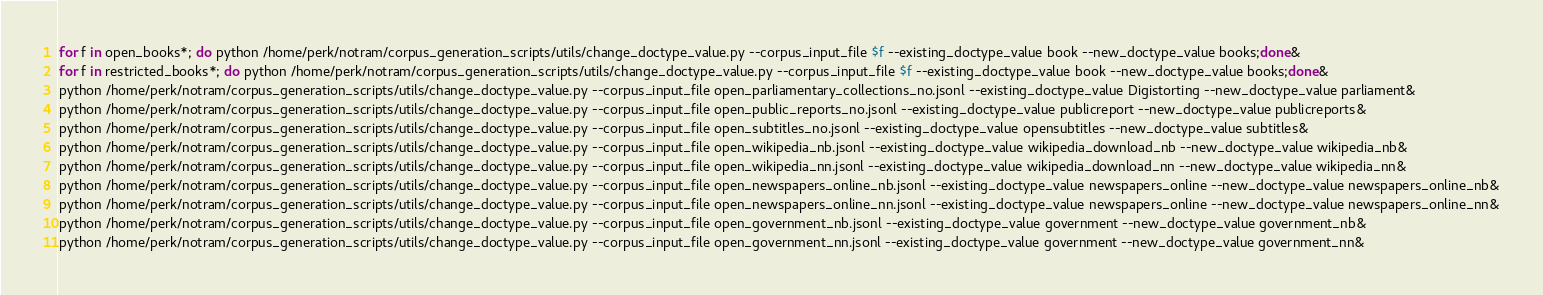<code> <loc_0><loc_0><loc_500><loc_500><_Bash_>for f in open_books*; do python /home/perk/notram/corpus_generation_scripts/utils/change_doctype_value.py --corpus_input_file $f --existing_doctype_value book --new_doctype_value books;done&
for f in restricted_books*; do python /home/perk/notram/corpus_generation_scripts/utils/change_doctype_value.py --corpus_input_file $f --existing_doctype_value book --new_doctype_value books;done&
python /home/perk/notram/corpus_generation_scripts/utils/change_doctype_value.py --corpus_input_file open_parliamentary_collections_no.jsonl --existing_doctype_value Digistorting --new_doctype_value parliament&
python /home/perk/notram/corpus_generation_scripts/utils/change_doctype_value.py --corpus_input_file open_public_reports_no.jsonl --existing_doctype_value publicreport --new_doctype_value publicreports&
python /home/perk/notram/corpus_generation_scripts/utils/change_doctype_value.py --corpus_input_file open_subtitles_no.jsonl --existing_doctype_value opensubtitles --new_doctype_value subtitles&
python /home/perk/notram/corpus_generation_scripts/utils/change_doctype_value.py --corpus_input_file open_wikipedia_nb.jsonl --existing_doctype_value wikipedia_download_nb --new_doctype_value wikipedia_nb&
python /home/perk/notram/corpus_generation_scripts/utils/change_doctype_value.py --corpus_input_file open_wikipedia_nn.jsonl --existing_doctype_value wikipedia_download_nn --new_doctype_value wikipedia_nn&
python /home/perk/notram/corpus_generation_scripts/utils/change_doctype_value.py --corpus_input_file open_newspapers_online_nb.jsonl --existing_doctype_value newspapers_online --new_doctype_value newspapers_online_nb&
python /home/perk/notram/corpus_generation_scripts/utils/change_doctype_value.py --corpus_input_file open_newspapers_online_nn.jsonl --existing_doctype_value newspapers_online --new_doctype_value newspapers_online_nn&
python /home/perk/notram/corpus_generation_scripts/utils/change_doctype_value.py --corpus_input_file open_government_nb.jsonl --existing_doctype_value government --new_doctype_value government_nb&
python /home/perk/notram/corpus_generation_scripts/utils/change_doctype_value.py --corpus_input_file open_government_nn.jsonl --existing_doctype_value government --new_doctype_value government_nn&

</code> 